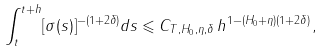Convert formula to latex. <formula><loc_0><loc_0><loc_500><loc_500>\int _ { t } ^ { t + h } [ \sigma ( s ) ] ^ { - ( 1 + 2 \delta ) } d s \leqslant C _ { T , H _ { 0 } , \eta , \delta } \, h ^ { 1 - ( H _ { 0 } + \eta ) ( 1 + 2 \delta ) } ,</formula> 